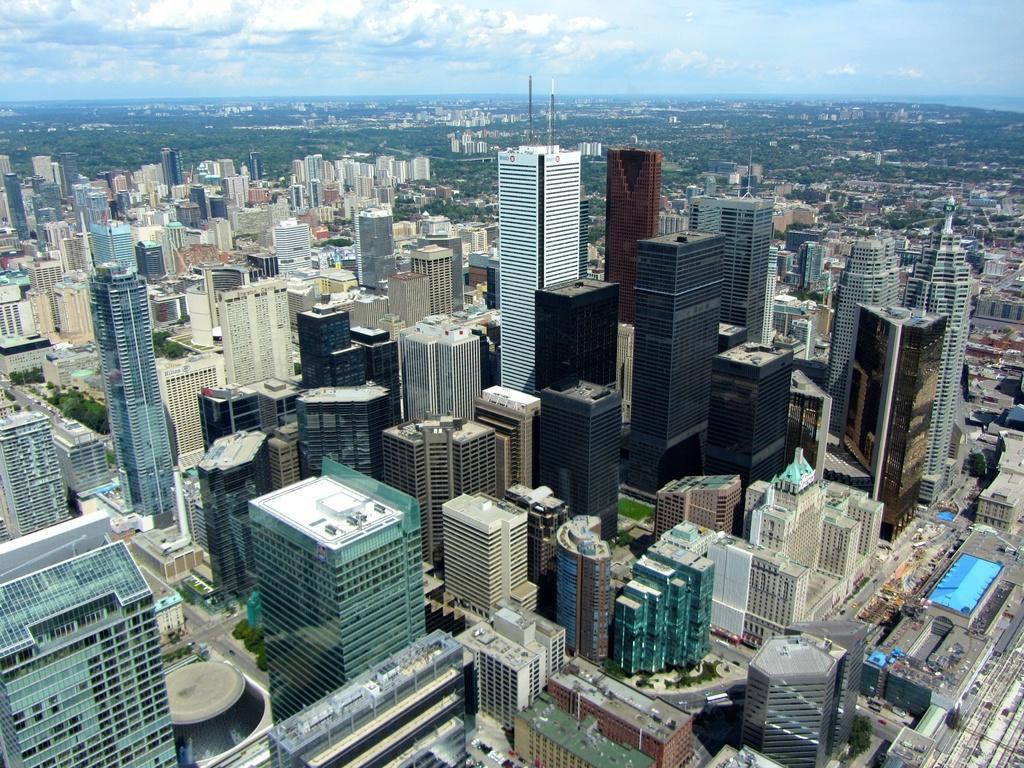Describe this image in one or two sentences. This image is an aerial view. In this image there are buildings and we can see roads. In the background there is sky. There are trees. 